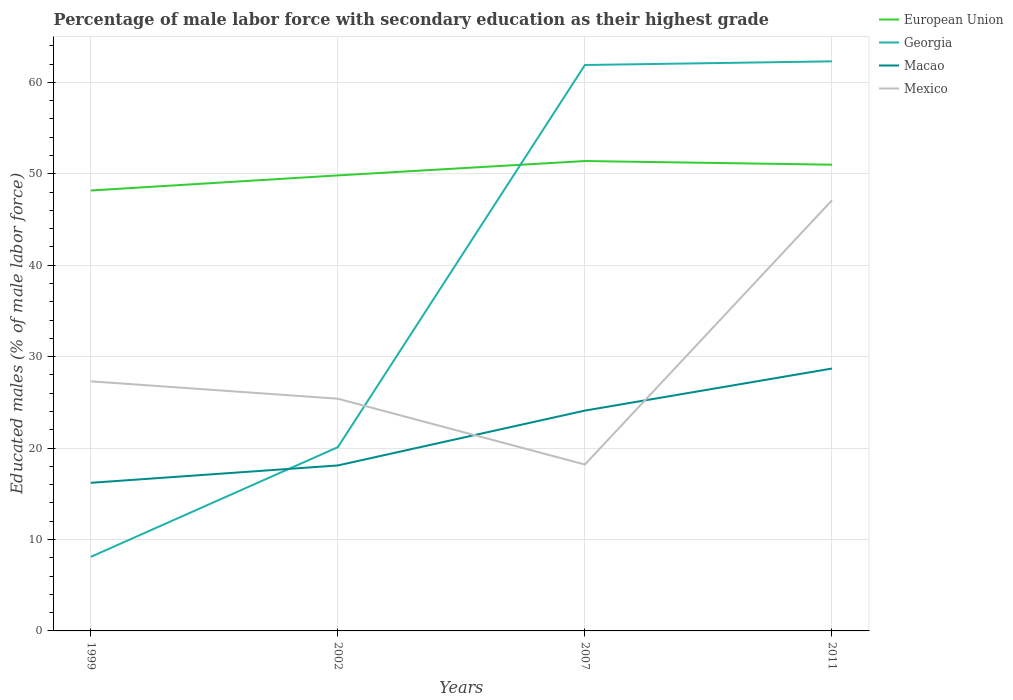How many different coloured lines are there?
Offer a terse response. 4. Does the line corresponding to Georgia intersect with the line corresponding to Mexico?
Offer a terse response. Yes. Is the number of lines equal to the number of legend labels?
Keep it short and to the point. Yes. Across all years, what is the maximum percentage of male labor force with secondary education in Georgia?
Provide a short and direct response. 8.1. In which year was the percentage of male labor force with secondary education in Georgia maximum?
Make the answer very short. 1999. What is the total percentage of male labor force with secondary education in Georgia in the graph?
Ensure brevity in your answer.  -54.2. What is the difference between the highest and the second highest percentage of male labor force with secondary education in Mexico?
Ensure brevity in your answer.  28.9. What is the difference between the highest and the lowest percentage of male labor force with secondary education in Macao?
Make the answer very short. 2. Are the values on the major ticks of Y-axis written in scientific E-notation?
Make the answer very short. No. How many legend labels are there?
Your response must be concise. 4. How are the legend labels stacked?
Provide a short and direct response. Vertical. What is the title of the graph?
Ensure brevity in your answer.  Percentage of male labor force with secondary education as their highest grade. Does "Guinea" appear as one of the legend labels in the graph?
Give a very brief answer. No. What is the label or title of the Y-axis?
Give a very brief answer. Educated males (% of male labor force). What is the Educated males (% of male labor force) in European Union in 1999?
Your response must be concise. 48.17. What is the Educated males (% of male labor force) of Georgia in 1999?
Ensure brevity in your answer.  8.1. What is the Educated males (% of male labor force) in Macao in 1999?
Offer a terse response. 16.2. What is the Educated males (% of male labor force) of Mexico in 1999?
Your answer should be compact. 27.3. What is the Educated males (% of male labor force) of European Union in 2002?
Your answer should be compact. 49.83. What is the Educated males (% of male labor force) of Georgia in 2002?
Provide a short and direct response. 20.1. What is the Educated males (% of male labor force) in Macao in 2002?
Ensure brevity in your answer.  18.1. What is the Educated males (% of male labor force) in Mexico in 2002?
Keep it short and to the point. 25.4. What is the Educated males (% of male labor force) of European Union in 2007?
Keep it short and to the point. 51.4. What is the Educated males (% of male labor force) in Georgia in 2007?
Provide a succinct answer. 61.9. What is the Educated males (% of male labor force) of Macao in 2007?
Offer a very short reply. 24.1. What is the Educated males (% of male labor force) of Mexico in 2007?
Provide a short and direct response. 18.2. What is the Educated males (% of male labor force) in European Union in 2011?
Give a very brief answer. 51. What is the Educated males (% of male labor force) of Georgia in 2011?
Ensure brevity in your answer.  62.3. What is the Educated males (% of male labor force) in Macao in 2011?
Offer a terse response. 28.7. What is the Educated males (% of male labor force) in Mexico in 2011?
Make the answer very short. 47.1. Across all years, what is the maximum Educated males (% of male labor force) of European Union?
Offer a very short reply. 51.4. Across all years, what is the maximum Educated males (% of male labor force) of Georgia?
Ensure brevity in your answer.  62.3. Across all years, what is the maximum Educated males (% of male labor force) of Macao?
Make the answer very short. 28.7. Across all years, what is the maximum Educated males (% of male labor force) in Mexico?
Provide a short and direct response. 47.1. Across all years, what is the minimum Educated males (% of male labor force) in European Union?
Make the answer very short. 48.17. Across all years, what is the minimum Educated males (% of male labor force) in Georgia?
Give a very brief answer. 8.1. Across all years, what is the minimum Educated males (% of male labor force) in Macao?
Offer a very short reply. 16.2. Across all years, what is the minimum Educated males (% of male labor force) in Mexico?
Ensure brevity in your answer.  18.2. What is the total Educated males (% of male labor force) in European Union in the graph?
Your response must be concise. 200.39. What is the total Educated males (% of male labor force) in Georgia in the graph?
Offer a terse response. 152.4. What is the total Educated males (% of male labor force) in Macao in the graph?
Your answer should be very brief. 87.1. What is the total Educated males (% of male labor force) in Mexico in the graph?
Ensure brevity in your answer.  118. What is the difference between the Educated males (% of male labor force) in European Union in 1999 and that in 2002?
Ensure brevity in your answer.  -1.65. What is the difference between the Educated males (% of male labor force) of Macao in 1999 and that in 2002?
Your response must be concise. -1.9. What is the difference between the Educated males (% of male labor force) in European Union in 1999 and that in 2007?
Your answer should be very brief. -3.22. What is the difference between the Educated males (% of male labor force) of Georgia in 1999 and that in 2007?
Ensure brevity in your answer.  -53.8. What is the difference between the Educated males (% of male labor force) of Mexico in 1999 and that in 2007?
Offer a terse response. 9.1. What is the difference between the Educated males (% of male labor force) in European Union in 1999 and that in 2011?
Provide a succinct answer. -2.82. What is the difference between the Educated males (% of male labor force) of Georgia in 1999 and that in 2011?
Keep it short and to the point. -54.2. What is the difference between the Educated males (% of male labor force) in Macao in 1999 and that in 2011?
Provide a succinct answer. -12.5. What is the difference between the Educated males (% of male labor force) in Mexico in 1999 and that in 2011?
Provide a short and direct response. -19.8. What is the difference between the Educated males (% of male labor force) of European Union in 2002 and that in 2007?
Give a very brief answer. -1.57. What is the difference between the Educated males (% of male labor force) of Georgia in 2002 and that in 2007?
Provide a short and direct response. -41.8. What is the difference between the Educated males (% of male labor force) in Macao in 2002 and that in 2007?
Your answer should be very brief. -6. What is the difference between the Educated males (% of male labor force) of Mexico in 2002 and that in 2007?
Your response must be concise. 7.2. What is the difference between the Educated males (% of male labor force) in European Union in 2002 and that in 2011?
Give a very brief answer. -1.17. What is the difference between the Educated males (% of male labor force) in Georgia in 2002 and that in 2011?
Offer a very short reply. -42.2. What is the difference between the Educated males (% of male labor force) of Mexico in 2002 and that in 2011?
Your response must be concise. -21.7. What is the difference between the Educated males (% of male labor force) in European Union in 2007 and that in 2011?
Your response must be concise. 0.4. What is the difference between the Educated males (% of male labor force) in Mexico in 2007 and that in 2011?
Make the answer very short. -28.9. What is the difference between the Educated males (% of male labor force) of European Union in 1999 and the Educated males (% of male labor force) of Georgia in 2002?
Ensure brevity in your answer.  28.07. What is the difference between the Educated males (% of male labor force) in European Union in 1999 and the Educated males (% of male labor force) in Macao in 2002?
Your response must be concise. 30.07. What is the difference between the Educated males (% of male labor force) in European Union in 1999 and the Educated males (% of male labor force) in Mexico in 2002?
Make the answer very short. 22.77. What is the difference between the Educated males (% of male labor force) of Georgia in 1999 and the Educated males (% of male labor force) of Mexico in 2002?
Make the answer very short. -17.3. What is the difference between the Educated males (% of male labor force) of Macao in 1999 and the Educated males (% of male labor force) of Mexico in 2002?
Offer a very short reply. -9.2. What is the difference between the Educated males (% of male labor force) in European Union in 1999 and the Educated males (% of male labor force) in Georgia in 2007?
Provide a succinct answer. -13.73. What is the difference between the Educated males (% of male labor force) of European Union in 1999 and the Educated males (% of male labor force) of Macao in 2007?
Your response must be concise. 24.07. What is the difference between the Educated males (% of male labor force) of European Union in 1999 and the Educated males (% of male labor force) of Mexico in 2007?
Offer a very short reply. 29.97. What is the difference between the Educated males (% of male labor force) of Georgia in 1999 and the Educated males (% of male labor force) of Macao in 2007?
Offer a very short reply. -16. What is the difference between the Educated males (% of male labor force) in European Union in 1999 and the Educated males (% of male labor force) in Georgia in 2011?
Ensure brevity in your answer.  -14.13. What is the difference between the Educated males (% of male labor force) of European Union in 1999 and the Educated males (% of male labor force) of Macao in 2011?
Your response must be concise. 19.47. What is the difference between the Educated males (% of male labor force) of European Union in 1999 and the Educated males (% of male labor force) of Mexico in 2011?
Give a very brief answer. 1.07. What is the difference between the Educated males (% of male labor force) of Georgia in 1999 and the Educated males (% of male labor force) of Macao in 2011?
Make the answer very short. -20.6. What is the difference between the Educated males (% of male labor force) of Georgia in 1999 and the Educated males (% of male labor force) of Mexico in 2011?
Make the answer very short. -39. What is the difference between the Educated males (% of male labor force) in Macao in 1999 and the Educated males (% of male labor force) in Mexico in 2011?
Your response must be concise. -30.9. What is the difference between the Educated males (% of male labor force) in European Union in 2002 and the Educated males (% of male labor force) in Georgia in 2007?
Your answer should be compact. -12.07. What is the difference between the Educated males (% of male labor force) of European Union in 2002 and the Educated males (% of male labor force) of Macao in 2007?
Provide a short and direct response. 25.73. What is the difference between the Educated males (% of male labor force) in European Union in 2002 and the Educated males (% of male labor force) in Mexico in 2007?
Ensure brevity in your answer.  31.63. What is the difference between the Educated males (% of male labor force) in Georgia in 2002 and the Educated males (% of male labor force) in Macao in 2007?
Offer a very short reply. -4. What is the difference between the Educated males (% of male labor force) of Georgia in 2002 and the Educated males (% of male labor force) of Mexico in 2007?
Your response must be concise. 1.9. What is the difference between the Educated males (% of male labor force) in European Union in 2002 and the Educated males (% of male labor force) in Georgia in 2011?
Offer a very short reply. -12.47. What is the difference between the Educated males (% of male labor force) of European Union in 2002 and the Educated males (% of male labor force) of Macao in 2011?
Keep it short and to the point. 21.13. What is the difference between the Educated males (% of male labor force) of European Union in 2002 and the Educated males (% of male labor force) of Mexico in 2011?
Keep it short and to the point. 2.73. What is the difference between the Educated males (% of male labor force) of Georgia in 2002 and the Educated males (% of male labor force) of Macao in 2011?
Your response must be concise. -8.6. What is the difference between the Educated males (% of male labor force) of Georgia in 2002 and the Educated males (% of male labor force) of Mexico in 2011?
Your response must be concise. -27. What is the difference between the Educated males (% of male labor force) of European Union in 2007 and the Educated males (% of male labor force) of Georgia in 2011?
Your answer should be compact. -10.9. What is the difference between the Educated males (% of male labor force) of European Union in 2007 and the Educated males (% of male labor force) of Macao in 2011?
Keep it short and to the point. 22.7. What is the difference between the Educated males (% of male labor force) of European Union in 2007 and the Educated males (% of male labor force) of Mexico in 2011?
Provide a short and direct response. 4.3. What is the difference between the Educated males (% of male labor force) in Georgia in 2007 and the Educated males (% of male labor force) in Macao in 2011?
Your answer should be very brief. 33.2. What is the difference between the Educated males (% of male labor force) in Georgia in 2007 and the Educated males (% of male labor force) in Mexico in 2011?
Provide a succinct answer. 14.8. What is the difference between the Educated males (% of male labor force) of Macao in 2007 and the Educated males (% of male labor force) of Mexico in 2011?
Offer a terse response. -23. What is the average Educated males (% of male labor force) in European Union per year?
Provide a succinct answer. 50.1. What is the average Educated males (% of male labor force) in Georgia per year?
Ensure brevity in your answer.  38.1. What is the average Educated males (% of male labor force) of Macao per year?
Give a very brief answer. 21.77. What is the average Educated males (% of male labor force) of Mexico per year?
Give a very brief answer. 29.5. In the year 1999, what is the difference between the Educated males (% of male labor force) in European Union and Educated males (% of male labor force) in Georgia?
Make the answer very short. 40.07. In the year 1999, what is the difference between the Educated males (% of male labor force) in European Union and Educated males (% of male labor force) in Macao?
Keep it short and to the point. 31.97. In the year 1999, what is the difference between the Educated males (% of male labor force) in European Union and Educated males (% of male labor force) in Mexico?
Provide a succinct answer. 20.87. In the year 1999, what is the difference between the Educated males (% of male labor force) in Georgia and Educated males (% of male labor force) in Macao?
Offer a terse response. -8.1. In the year 1999, what is the difference between the Educated males (% of male labor force) of Georgia and Educated males (% of male labor force) of Mexico?
Ensure brevity in your answer.  -19.2. In the year 1999, what is the difference between the Educated males (% of male labor force) of Macao and Educated males (% of male labor force) of Mexico?
Your answer should be compact. -11.1. In the year 2002, what is the difference between the Educated males (% of male labor force) in European Union and Educated males (% of male labor force) in Georgia?
Keep it short and to the point. 29.73. In the year 2002, what is the difference between the Educated males (% of male labor force) in European Union and Educated males (% of male labor force) in Macao?
Provide a short and direct response. 31.73. In the year 2002, what is the difference between the Educated males (% of male labor force) in European Union and Educated males (% of male labor force) in Mexico?
Offer a very short reply. 24.43. In the year 2002, what is the difference between the Educated males (% of male labor force) in Georgia and Educated males (% of male labor force) in Mexico?
Provide a succinct answer. -5.3. In the year 2002, what is the difference between the Educated males (% of male labor force) of Macao and Educated males (% of male labor force) of Mexico?
Provide a short and direct response. -7.3. In the year 2007, what is the difference between the Educated males (% of male labor force) in European Union and Educated males (% of male labor force) in Georgia?
Your answer should be compact. -10.5. In the year 2007, what is the difference between the Educated males (% of male labor force) in European Union and Educated males (% of male labor force) in Macao?
Keep it short and to the point. 27.3. In the year 2007, what is the difference between the Educated males (% of male labor force) of European Union and Educated males (% of male labor force) of Mexico?
Offer a terse response. 33.2. In the year 2007, what is the difference between the Educated males (% of male labor force) of Georgia and Educated males (% of male labor force) of Macao?
Ensure brevity in your answer.  37.8. In the year 2007, what is the difference between the Educated males (% of male labor force) of Georgia and Educated males (% of male labor force) of Mexico?
Your answer should be very brief. 43.7. In the year 2007, what is the difference between the Educated males (% of male labor force) of Macao and Educated males (% of male labor force) of Mexico?
Ensure brevity in your answer.  5.9. In the year 2011, what is the difference between the Educated males (% of male labor force) in European Union and Educated males (% of male labor force) in Georgia?
Offer a terse response. -11.3. In the year 2011, what is the difference between the Educated males (% of male labor force) in European Union and Educated males (% of male labor force) in Macao?
Keep it short and to the point. 22.3. In the year 2011, what is the difference between the Educated males (% of male labor force) of European Union and Educated males (% of male labor force) of Mexico?
Make the answer very short. 3.9. In the year 2011, what is the difference between the Educated males (% of male labor force) of Georgia and Educated males (% of male labor force) of Macao?
Ensure brevity in your answer.  33.6. In the year 2011, what is the difference between the Educated males (% of male labor force) of Macao and Educated males (% of male labor force) of Mexico?
Keep it short and to the point. -18.4. What is the ratio of the Educated males (% of male labor force) of European Union in 1999 to that in 2002?
Offer a terse response. 0.97. What is the ratio of the Educated males (% of male labor force) of Georgia in 1999 to that in 2002?
Offer a terse response. 0.4. What is the ratio of the Educated males (% of male labor force) of Macao in 1999 to that in 2002?
Offer a very short reply. 0.9. What is the ratio of the Educated males (% of male labor force) in Mexico in 1999 to that in 2002?
Give a very brief answer. 1.07. What is the ratio of the Educated males (% of male labor force) of European Union in 1999 to that in 2007?
Provide a short and direct response. 0.94. What is the ratio of the Educated males (% of male labor force) of Georgia in 1999 to that in 2007?
Make the answer very short. 0.13. What is the ratio of the Educated males (% of male labor force) of Macao in 1999 to that in 2007?
Provide a succinct answer. 0.67. What is the ratio of the Educated males (% of male labor force) of European Union in 1999 to that in 2011?
Your answer should be very brief. 0.94. What is the ratio of the Educated males (% of male labor force) in Georgia in 1999 to that in 2011?
Make the answer very short. 0.13. What is the ratio of the Educated males (% of male labor force) in Macao in 1999 to that in 2011?
Your answer should be compact. 0.56. What is the ratio of the Educated males (% of male labor force) of Mexico in 1999 to that in 2011?
Offer a terse response. 0.58. What is the ratio of the Educated males (% of male labor force) in European Union in 2002 to that in 2007?
Offer a terse response. 0.97. What is the ratio of the Educated males (% of male labor force) in Georgia in 2002 to that in 2007?
Keep it short and to the point. 0.32. What is the ratio of the Educated males (% of male labor force) in Macao in 2002 to that in 2007?
Keep it short and to the point. 0.75. What is the ratio of the Educated males (% of male labor force) of Mexico in 2002 to that in 2007?
Offer a terse response. 1.4. What is the ratio of the Educated males (% of male labor force) in Georgia in 2002 to that in 2011?
Provide a succinct answer. 0.32. What is the ratio of the Educated males (% of male labor force) of Macao in 2002 to that in 2011?
Ensure brevity in your answer.  0.63. What is the ratio of the Educated males (% of male labor force) of Mexico in 2002 to that in 2011?
Make the answer very short. 0.54. What is the ratio of the Educated males (% of male labor force) in European Union in 2007 to that in 2011?
Keep it short and to the point. 1.01. What is the ratio of the Educated males (% of male labor force) in Macao in 2007 to that in 2011?
Your response must be concise. 0.84. What is the ratio of the Educated males (% of male labor force) in Mexico in 2007 to that in 2011?
Your response must be concise. 0.39. What is the difference between the highest and the second highest Educated males (% of male labor force) of European Union?
Provide a succinct answer. 0.4. What is the difference between the highest and the second highest Educated males (% of male labor force) of Macao?
Provide a short and direct response. 4.6. What is the difference between the highest and the second highest Educated males (% of male labor force) of Mexico?
Your answer should be very brief. 19.8. What is the difference between the highest and the lowest Educated males (% of male labor force) of European Union?
Provide a succinct answer. 3.22. What is the difference between the highest and the lowest Educated males (% of male labor force) in Georgia?
Keep it short and to the point. 54.2. What is the difference between the highest and the lowest Educated males (% of male labor force) in Mexico?
Offer a terse response. 28.9. 